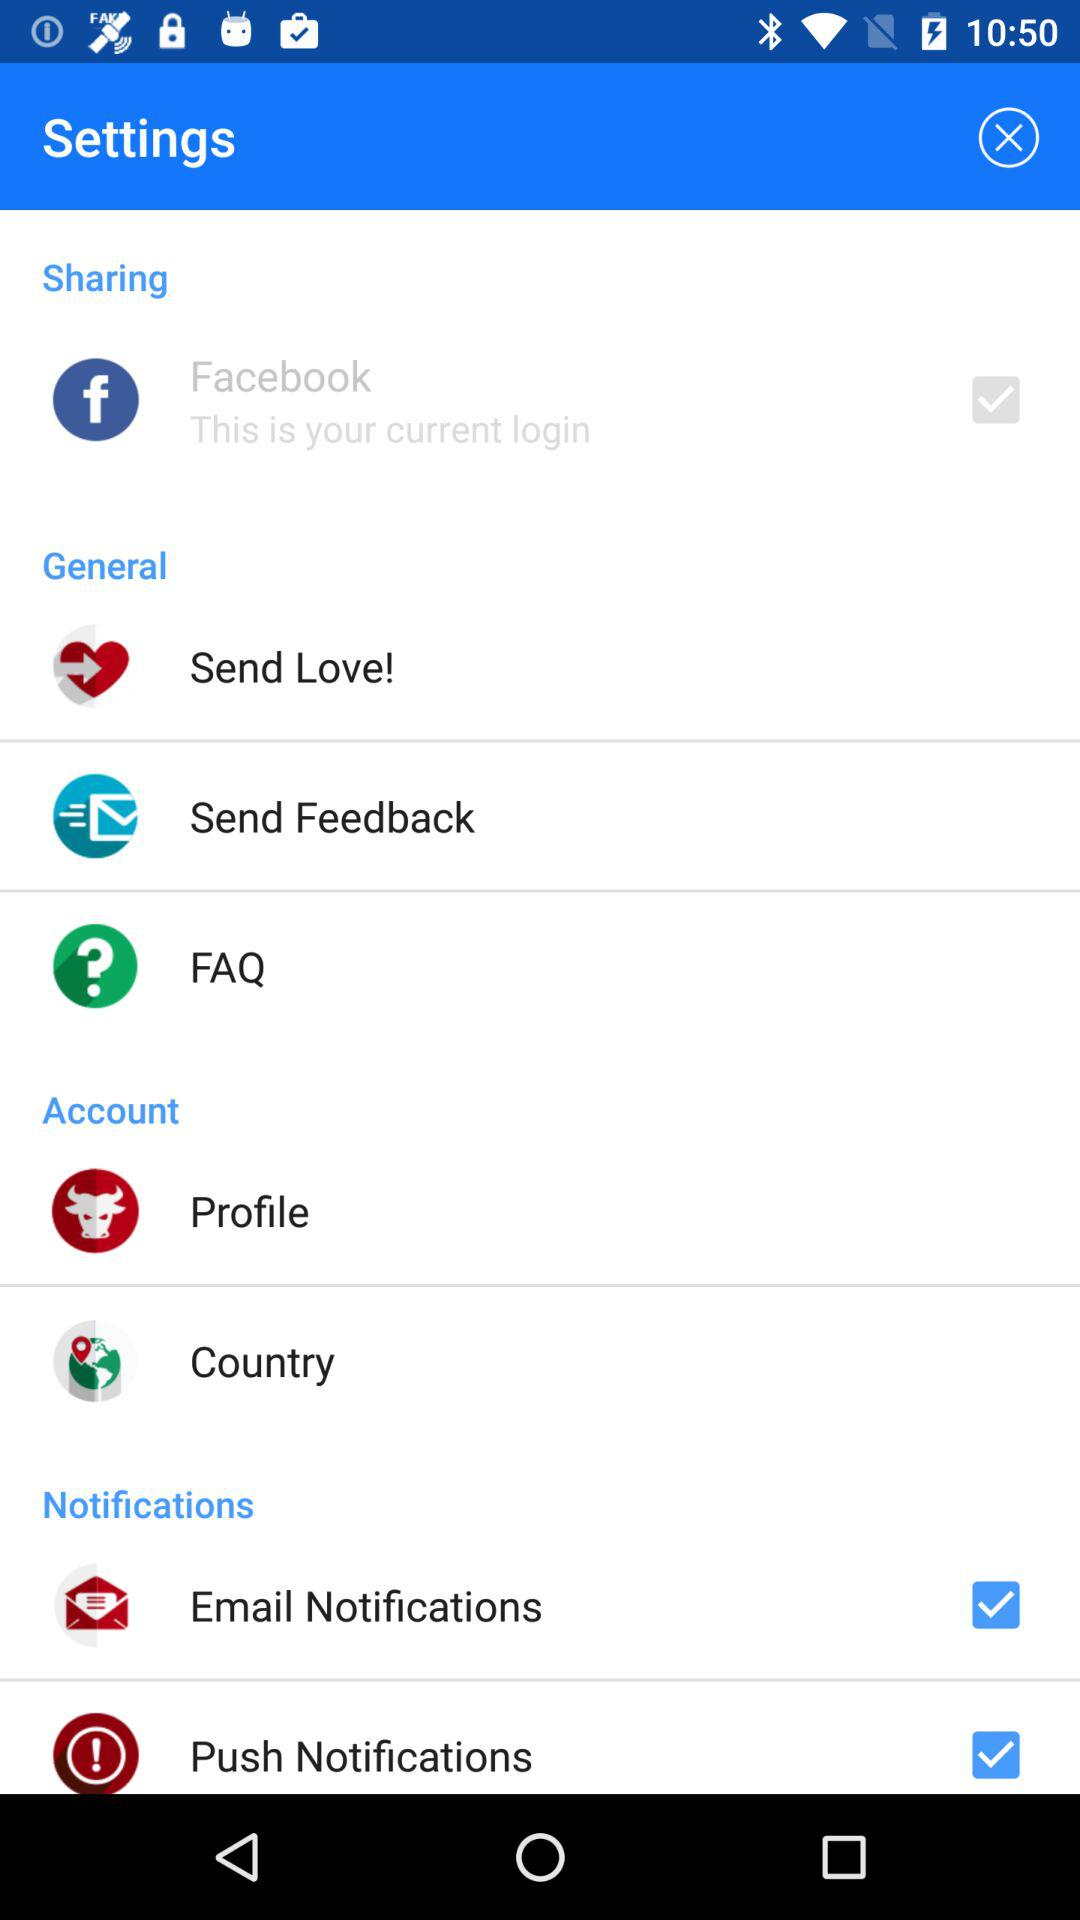What's the status of "Email Notifications"? The status is "on". 